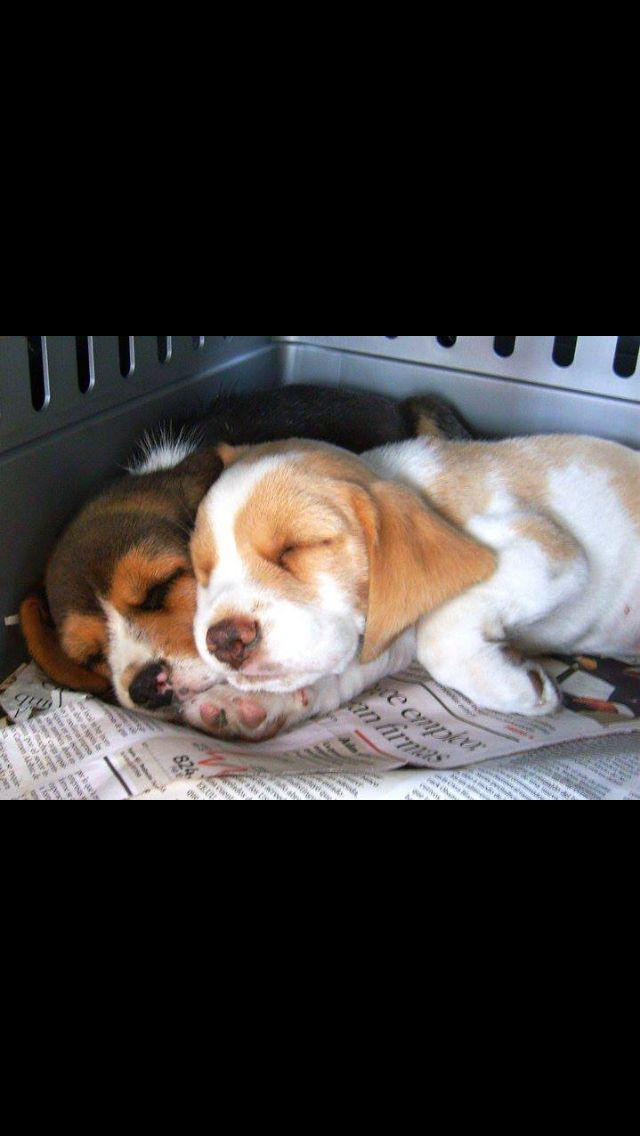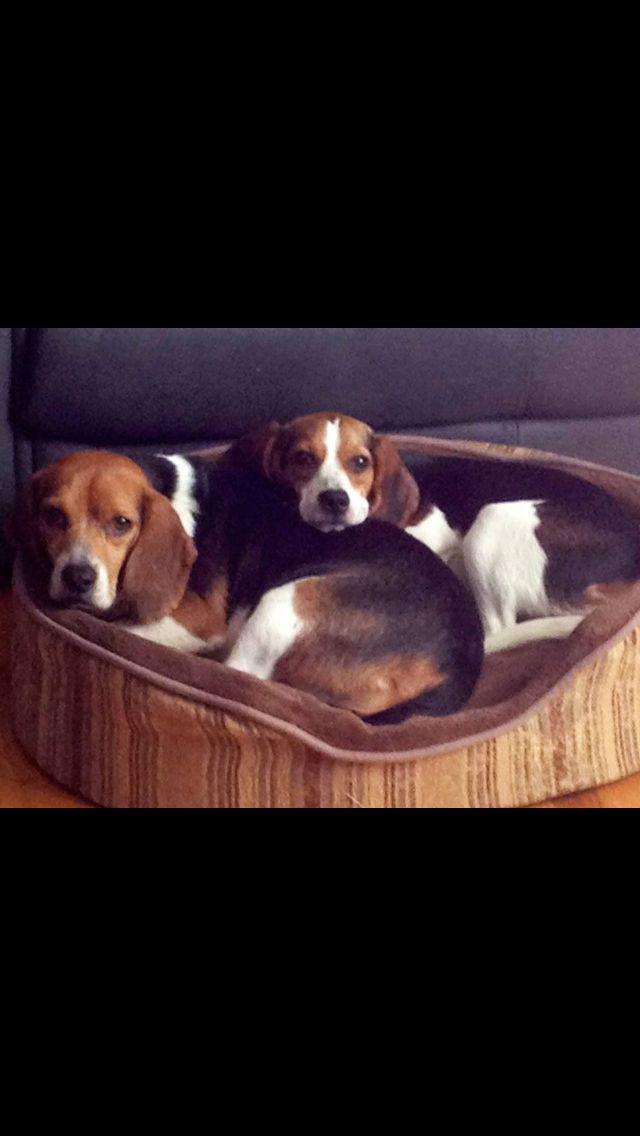The first image is the image on the left, the second image is the image on the right. Given the left and right images, does the statement "Right image shows beagles sleeping in a soft-sided roundish pet bed." hold true? Answer yes or no. Yes. The first image is the image on the left, the second image is the image on the right. Analyze the images presented: Is the assertion "Two dogs are sleeping together in one of the images." valid? Answer yes or no. Yes. 